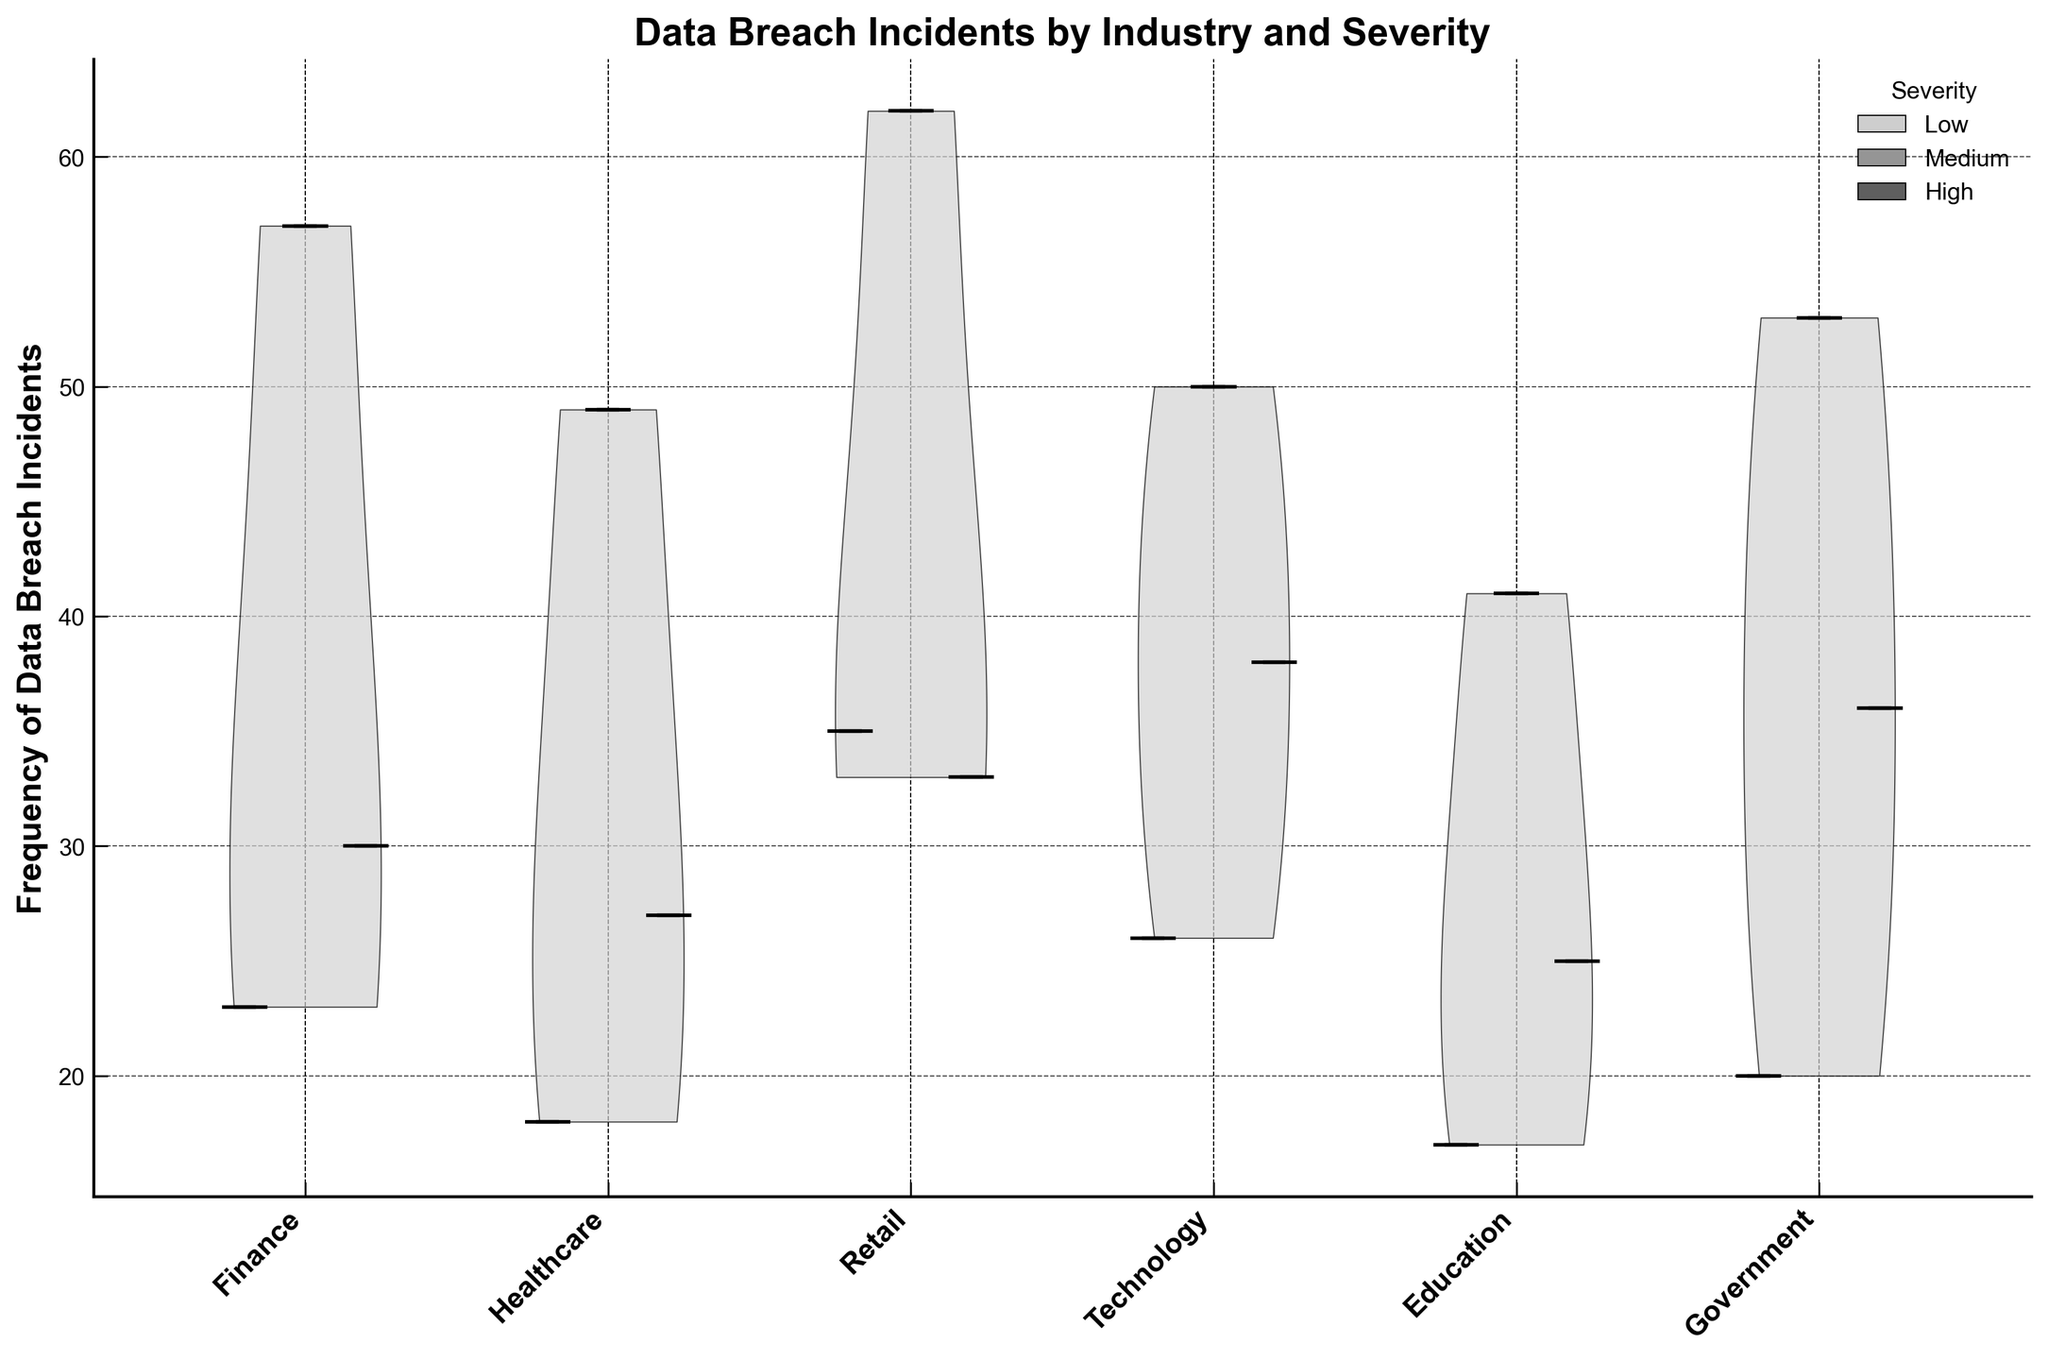What is the title of the figure? The title of the figure is displayed at the top of the plot. The title provides a concise description of what the figure represents.
Answer: Data Breach Incidents by Industry and Severity Which industry has the highest median frequency of data breach incidents in the 'Low' severity category? Look for the 'Low' category within each box plot and compare the median markers. The industry with the highest median marker represents the highest median frequency.
Answer: Retail What is the range of frequencies for the 'High' severity category in the Healthcare industry? Identify the box plot corresponding to 'High' severity within the Healthcare industry. The range is the difference between the highest and lowest whiskers.
Answer: 27 to 27 Which industry shows the highest variability (spread) in frequency of data breach incidents for the 'Medium' severity category? Locate the box plots for the 'Medium' severity category. The industry with the widest interquartile range (IQR) has the highest variability.
Answer: Retail How does the median frequency of data breach incidents in the Finance industry compare between 'Medium' and 'High' severity categories? Compare the median markers of 'Medium' and 'High' severity box plots within the Finance industry.
Answer: The 'High' category has a lower median than the 'Medium' category Which industry has the lowest median frequency in the 'Medium' severity category? Look at the median markers of the 'Medium' severity box plot for each industry and find the one with the lowest value.
Answer: Education How does the overall distribution of frequencies in Government compare to that in Technology across all severity levels? Analyze the shapes of the violin plots for Government and Technology. Check the spread and density of data points within the violins.
Answer: Government has a narrower distribution with more concentrated frequencies, while Technology shows more spread and wider distribution What is the general trend of data breach frequencies as severity increases within the Retail industry? Observe the position of medians in the box plots for 'Low', 'Medium', and 'High' severity categories within the Retail industry.
Answer: The frequency generally increases from 'Low' to 'Medium' but decreases slightly in 'High' How do the interquartile ranges (IQRs) compare between the Finance and Healthcare industries for 'Medium' severity? The IQR is determined by the box height. Compare the box heights of 'Medium' severity between Finance and Healthcare.
Answer: Finance has a slightly larger IQR compared to Healthcare 